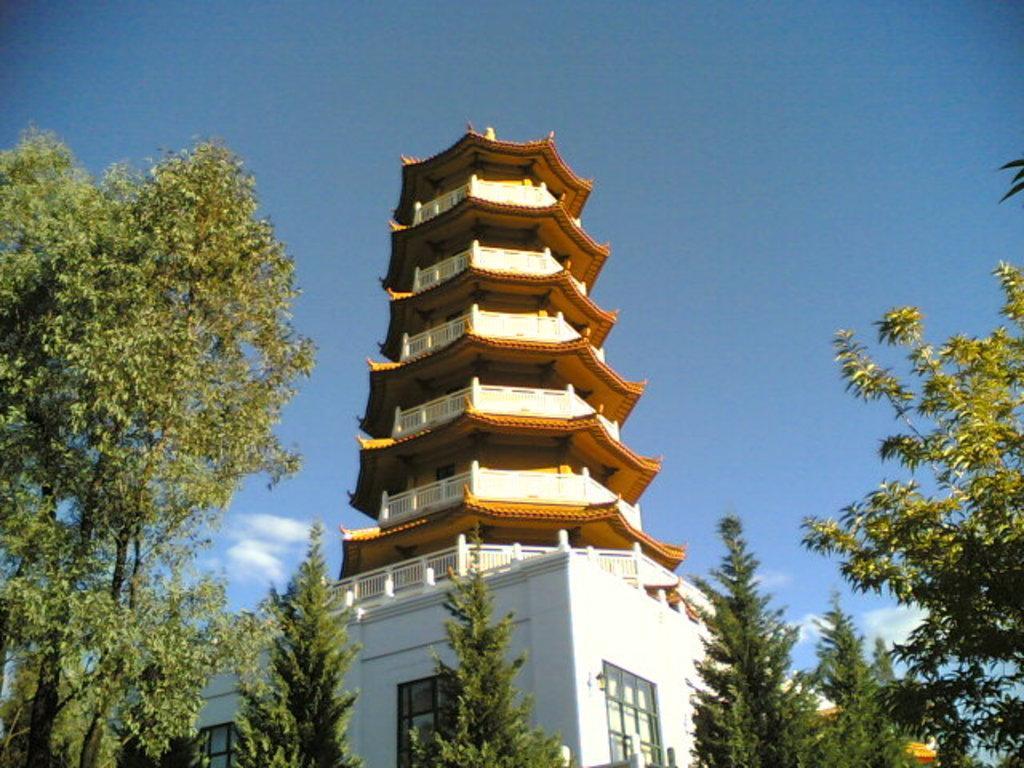Please provide a concise description of this image. In this picture there is a Pagoda and there are few trees in front of it and the sky is in blue color. 